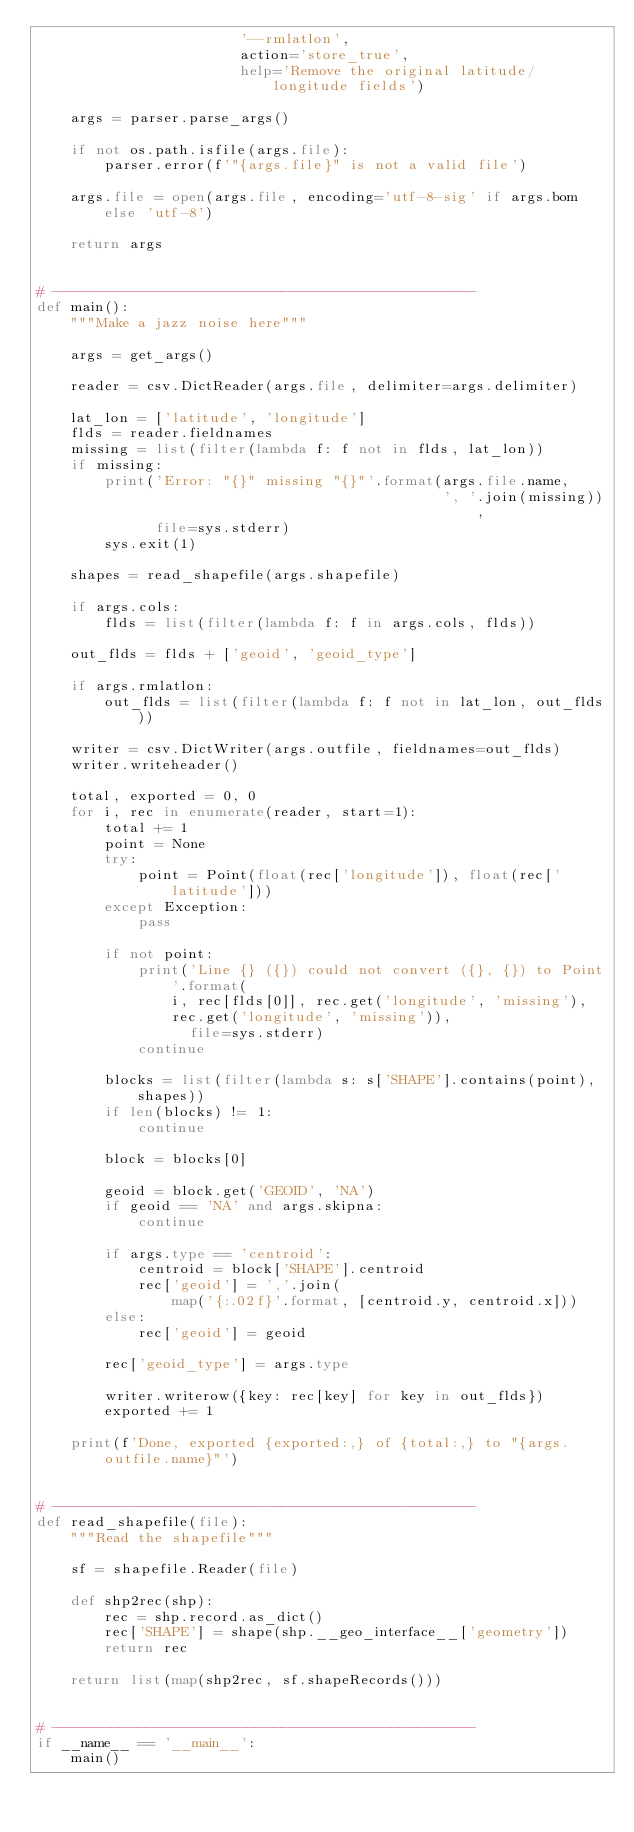Convert code to text. <code><loc_0><loc_0><loc_500><loc_500><_Python_>                        '--rmlatlon',
                        action='store_true',
                        help='Remove the original latitude/longitude fields')

    args = parser.parse_args()

    if not os.path.isfile(args.file):
        parser.error(f'"{args.file}" is not a valid file')

    args.file = open(args.file, encoding='utf-8-sig' if args.bom else 'utf-8')

    return args


# --------------------------------------------------
def main():
    """Make a jazz noise here"""

    args = get_args()

    reader = csv.DictReader(args.file, delimiter=args.delimiter)

    lat_lon = ['latitude', 'longitude']
    flds = reader.fieldnames
    missing = list(filter(lambda f: f not in flds, lat_lon))
    if missing:
        print('Error: "{}" missing "{}"'.format(args.file.name,
                                                ', '.join(missing)),
              file=sys.stderr)
        sys.exit(1)

    shapes = read_shapefile(args.shapefile)

    if args.cols:
        flds = list(filter(lambda f: f in args.cols, flds))

    out_flds = flds + ['geoid', 'geoid_type']

    if args.rmlatlon:
        out_flds = list(filter(lambda f: f not in lat_lon, out_flds))

    writer = csv.DictWriter(args.outfile, fieldnames=out_flds)
    writer.writeheader()

    total, exported = 0, 0
    for i, rec in enumerate(reader, start=1):
        total += 1
        point = None
        try:
            point = Point(float(rec['longitude']), float(rec['latitude']))
        except Exception:
            pass

        if not point:
            print('Line {} ({}) could not convert ({}, {}) to Point'.format(
                i, rec[flds[0]], rec.get('longitude', 'missing'),
                rec.get('longitude', 'missing')),
                  file=sys.stderr)
            continue

        blocks = list(filter(lambda s: s['SHAPE'].contains(point), shapes))
        if len(blocks) != 1:
            continue

        block = blocks[0]

        geoid = block.get('GEOID', 'NA')
        if geoid == 'NA' and args.skipna:
            continue

        if args.type == 'centroid':
            centroid = block['SHAPE'].centroid
            rec['geoid'] = ','.join(
                map('{:.02f}'.format, [centroid.y, centroid.x]))
        else:
            rec['geoid'] = geoid

        rec['geoid_type'] = args.type

        writer.writerow({key: rec[key] for key in out_flds})
        exported += 1

    print(f'Done, exported {exported:,} of {total:,} to "{args.outfile.name}"')


# --------------------------------------------------
def read_shapefile(file):
    """Read the shapefile"""

    sf = shapefile.Reader(file)

    def shp2rec(shp):
        rec = shp.record.as_dict()
        rec['SHAPE'] = shape(shp.__geo_interface__['geometry'])
        return rec

    return list(map(shp2rec, sf.shapeRecords()))


# --------------------------------------------------
if __name__ == '__main__':
    main()
</code> 